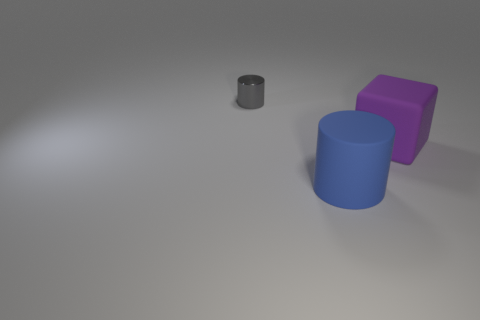Add 3 large yellow things. How many objects exist? 6 Subtract all cylinders. How many objects are left? 1 Subtract all purple shiny cylinders. Subtract all large purple things. How many objects are left? 2 Add 2 big blue matte objects. How many big blue matte objects are left? 3 Add 1 big matte objects. How many big matte objects exist? 3 Subtract 0 brown blocks. How many objects are left? 3 